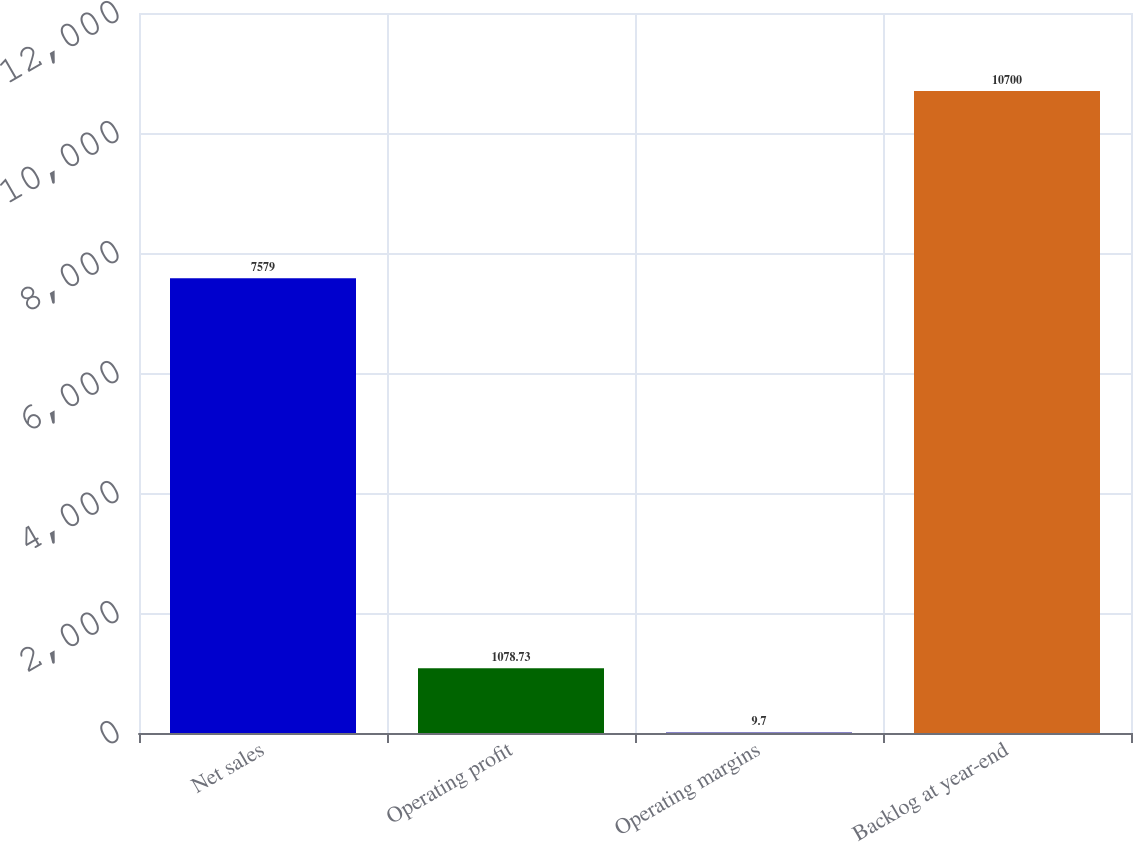Convert chart to OTSL. <chart><loc_0><loc_0><loc_500><loc_500><bar_chart><fcel>Net sales<fcel>Operating profit<fcel>Operating margins<fcel>Backlog at year-end<nl><fcel>7579<fcel>1078.73<fcel>9.7<fcel>10700<nl></chart> 